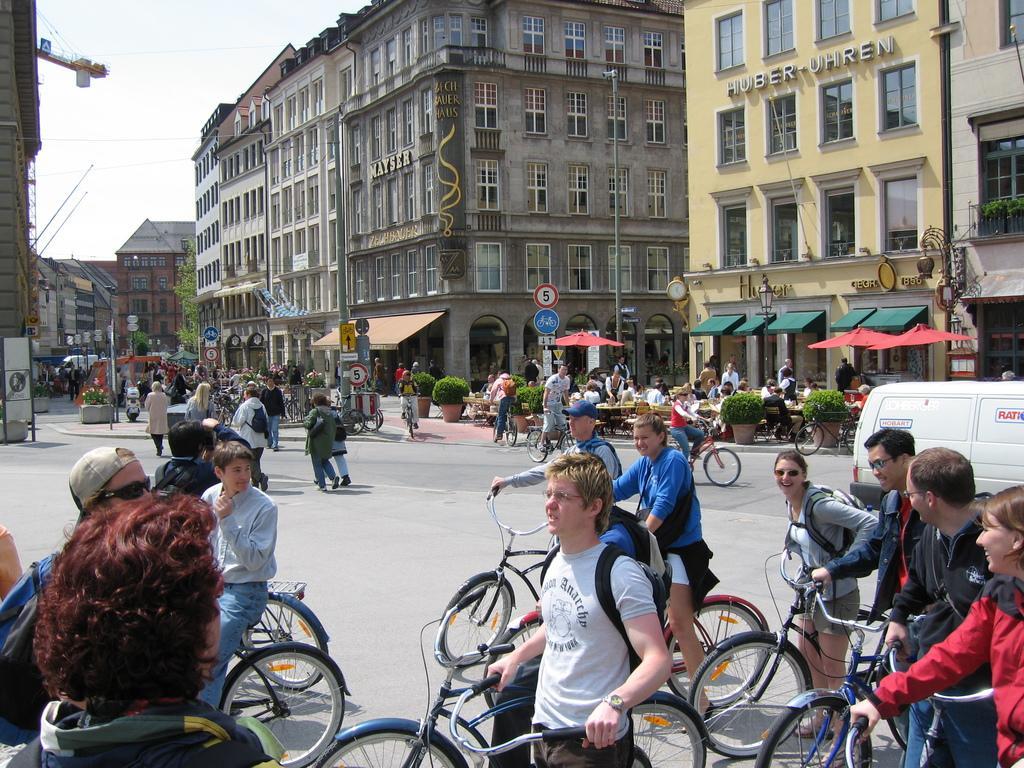Describe this image in one or two sentences. In this picture we can see a group of people standing on the road with their bicycles and some people are walking on the path. Behind the people there are poles with signboards, plants, buildings and a sky. 